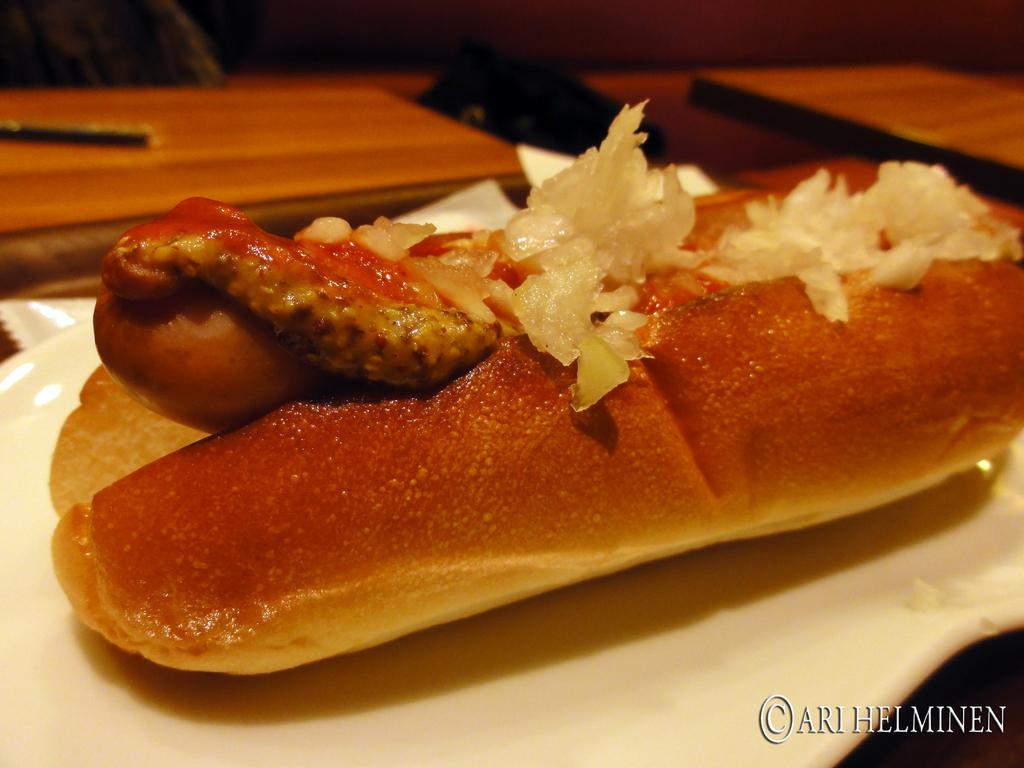What is on the plate that is visible in the image? There is food on the plate in the image. What can be seen in the background of the image? There are tables and other objects in the background of the image. Is there any text present in the image? Yes, there is text at the bottom of the image. How many hands are visible in the image? There are no hands visible in the image. Can you describe the haircut of the person in the image? There is no person present in the image, so it is not possible to describe their haircut. 